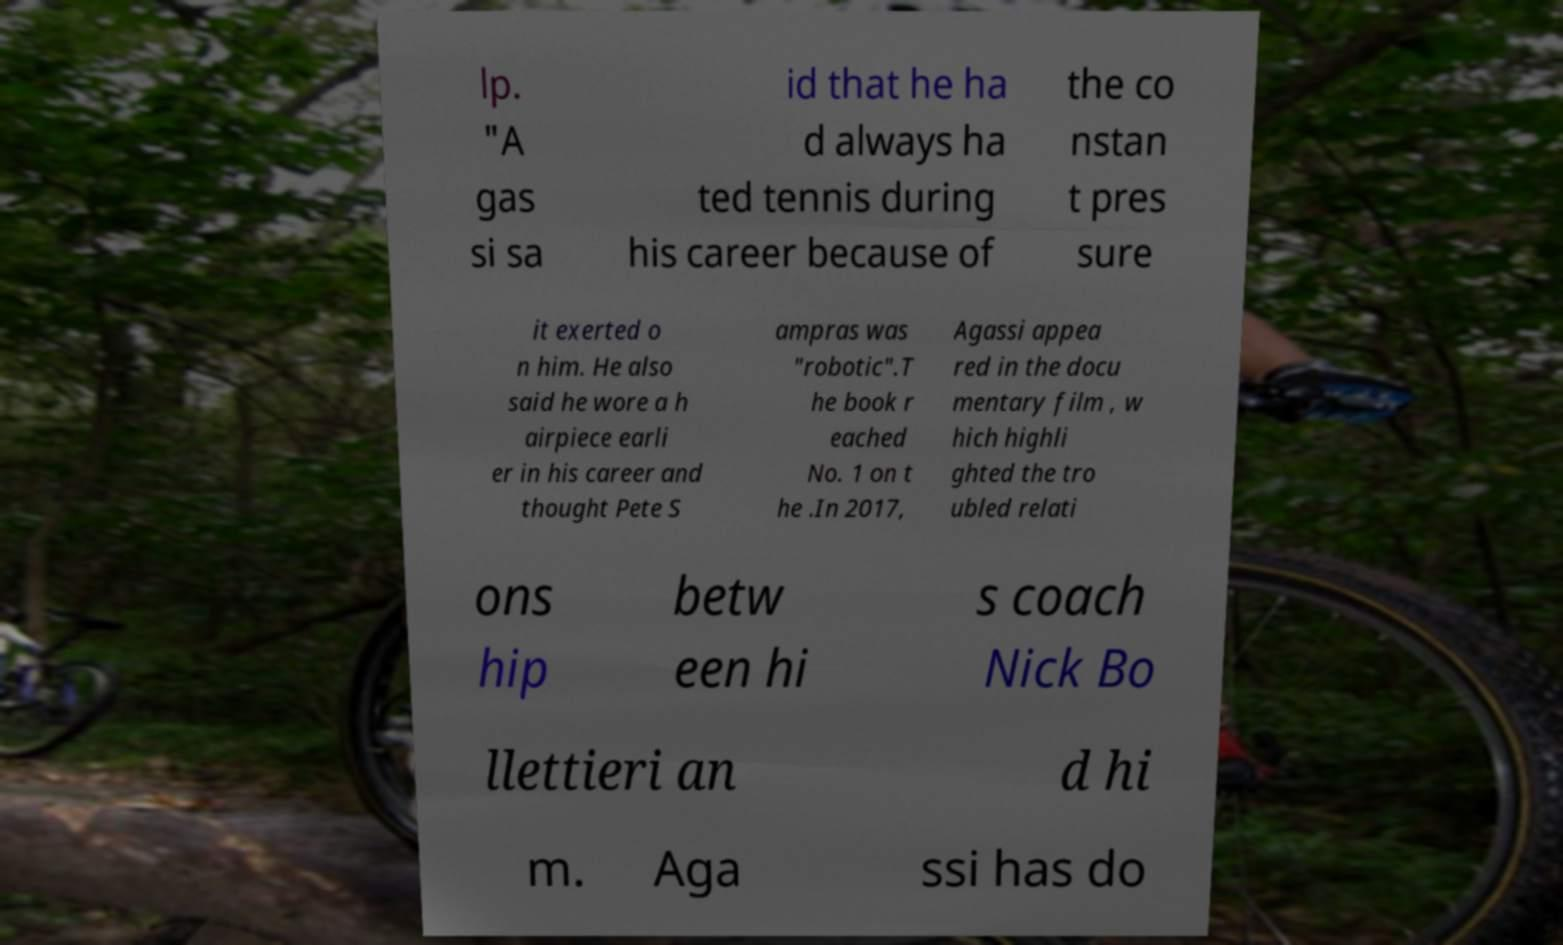Please identify and transcribe the text found in this image. lp. "A gas si sa id that he ha d always ha ted tennis during his career because of the co nstan t pres sure it exerted o n him. He also said he wore a h airpiece earli er in his career and thought Pete S ampras was "robotic".T he book r eached No. 1 on t he .In 2017, Agassi appea red in the docu mentary film , w hich highli ghted the tro ubled relati ons hip betw een hi s coach Nick Bo llettieri an d hi m. Aga ssi has do 